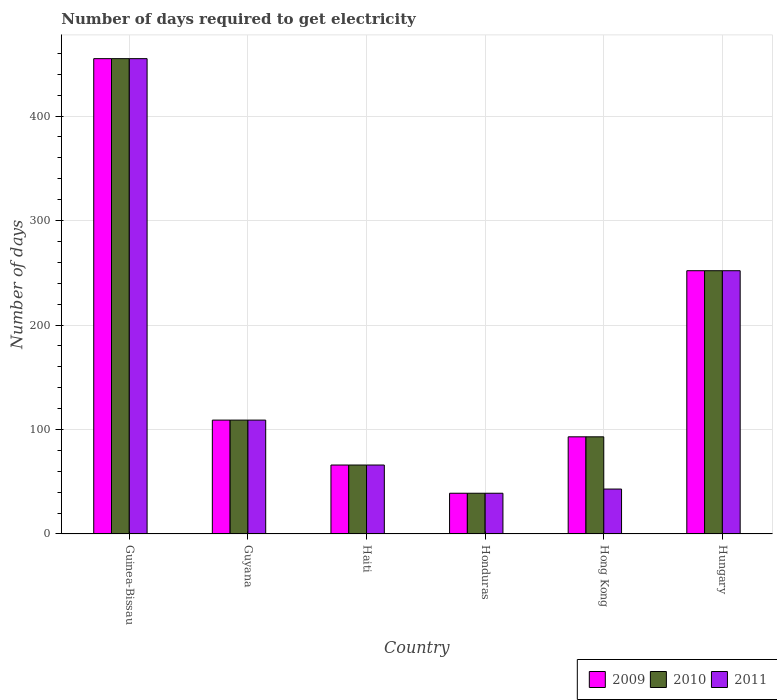Are the number of bars on each tick of the X-axis equal?
Make the answer very short. Yes. How many bars are there on the 6th tick from the right?
Offer a terse response. 3. What is the label of the 4th group of bars from the left?
Provide a succinct answer. Honduras. What is the number of days required to get electricity in in 2010 in Guyana?
Make the answer very short. 109. Across all countries, what is the maximum number of days required to get electricity in in 2009?
Give a very brief answer. 455. In which country was the number of days required to get electricity in in 2010 maximum?
Your response must be concise. Guinea-Bissau. In which country was the number of days required to get electricity in in 2011 minimum?
Offer a very short reply. Honduras. What is the total number of days required to get electricity in in 2010 in the graph?
Your answer should be very brief. 1014. What is the difference between the number of days required to get electricity in in 2009 in Guyana and that in Honduras?
Provide a succinct answer. 70. What is the average number of days required to get electricity in in 2011 per country?
Give a very brief answer. 160.67. In how many countries, is the number of days required to get electricity in in 2009 greater than 320 days?
Your answer should be compact. 1. What is the ratio of the number of days required to get electricity in in 2009 in Guyana to that in Hungary?
Provide a short and direct response. 0.43. Is the number of days required to get electricity in in 2009 in Guinea-Bissau less than that in Hong Kong?
Keep it short and to the point. No. What is the difference between the highest and the second highest number of days required to get electricity in in 2009?
Give a very brief answer. 143. What is the difference between the highest and the lowest number of days required to get electricity in in 2011?
Your answer should be very brief. 416. In how many countries, is the number of days required to get electricity in in 2009 greater than the average number of days required to get electricity in in 2009 taken over all countries?
Ensure brevity in your answer.  2. What does the 3rd bar from the left in Hungary represents?
Ensure brevity in your answer.  2011. Is it the case that in every country, the sum of the number of days required to get electricity in in 2011 and number of days required to get electricity in in 2010 is greater than the number of days required to get electricity in in 2009?
Provide a short and direct response. Yes. Are the values on the major ticks of Y-axis written in scientific E-notation?
Your answer should be very brief. No. Does the graph contain grids?
Your answer should be compact. Yes. Where does the legend appear in the graph?
Give a very brief answer. Bottom right. How many legend labels are there?
Give a very brief answer. 3. How are the legend labels stacked?
Provide a short and direct response. Horizontal. What is the title of the graph?
Offer a very short reply. Number of days required to get electricity. Does "2004" appear as one of the legend labels in the graph?
Make the answer very short. No. What is the label or title of the Y-axis?
Keep it short and to the point. Number of days. What is the Number of days in 2009 in Guinea-Bissau?
Provide a succinct answer. 455. What is the Number of days in 2010 in Guinea-Bissau?
Provide a short and direct response. 455. What is the Number of days of 2011 in Guinea-Bissau?
Provide a short and direct response. 455. What is the Number of days of 2009 in Guyana?
Ensure brevity in your answer.  109. What is the Number of days of 2010 in Guyana?
Ensure brevity in your answer.  109. What is the Number of days of 2011 in Guyana?
Your answer should be compact. 109. What is the Number of days in 2010 in Haiti?
Your response must be concise. 66. What is the Number of days in 2010 in Honduras?
Your answer should be very brief. 39. What is the Number of days in 2011 in Honduras?
Your answer should be compact. 39. What is the Number of days of 2009 in Hong Kong?
Keep it short and to the point. 93. What is the Number of days of 2010 in Hong Kong?
Offer a very short reply. 93. What is the Number of days in 2011 in Hong Kong?
Keep it short and to the point. 43. What is the Number of days in 2009 in Hungary?
Provide a short and direct response. 252. What is the Number of days of 2010 in Hungary?
Provide a succinct answer. 252. What is the Number of days in 2011 in Hungary?
Ensure brevity in your answer.  252. Across all countries, what is the maximum Number of days in 2009?
Ensure brevity in your answer.  455. Across all countries, what is the maximum Number of days in 2010?
Give a very brief answer. 455. Across all countries, what is the maximum Number of days of 2011?
Give a very brief answer. 455. Across all countries, what is the minimum Number of days in 2009?
Offer a terse response. 39. What is the total Number of days of 2009 in the graph?
Keep it short and to the point. 1014. What is the total Number of days of 2010 in the graph?
Ensure brevity in your answer.  1014. What is the total Number of days in 2011 in the graph?
Your answer should be very brief. 964. What is the difference between the Number of days in 2009 in Guinea-Bissau and that in Guyana?
Your response must be concise. 346. What is the difference between the Number of days in 2010 in Guinea-Bissau and that in Guyana?
Ensure brevity in your answer.  346. What is the difference between the Number of days of 2011 in Guinea-Bissau and that in Guyana?
Your response must be concise. 346. What is the difference between the Number of days in 2009 in Guinea-Bissau and that in Haiti?
Keep it short and to the point. 389. What is the difference between the Number of days in 2010 in Guinea-Bissau and that in Haiti?
Make the answer very short. 389. What is the difference between the Number of days of 2011 in Guinea-Bissau and that in Haiti?
Provide a short and direct response. 389. What is the difference between the Number of days of 2009 in Guinea-Bissau and that in Honduras?
Give a very brief answer. 416. What is the difference between the Number of days in 2010 in Guinea-Bissau and that in Honduras?
Your answer should be compact. 416. What is the difference between the Number of days in 2011 in Guinea-Bissau and that in Honduras?
Give a very brief answer. 416. What is the difference between the Number of days of 2009 in Guinea-Bissau and that in Hong Kong?
Give a very brief answer. 362. What is the difference between the Number of days in 2010 in Guinea-Bissau and that in Hong Kong?
Your answer should be very brief. 362. What is the difference between the Number of days of 2011 in Guinea-Bissau and that in Hong Kong?
Give a very brief answer. 412. What is the difference between the Number of days in 2009 in Guinea-Bissau and that in Hungary?
Ensure brevity in your answer.  203. What is the difference between the Number of days of 2010 in Guinea-Bissau and that in Hungary?
Provide a short and direct response. 203. What is the difference between the Number of days in 2011 in Guinea-Bissau and that in Hungary?
Your response must be concise. 203. What is the difference between the Number of days of 2009 in Guyana and that in Honduras?
Make the answer very short. 70. What is the difference between the Number of days of 2010 in Guyana and that in Honduras?
Your response must be concise. 70. What is the difference between the Number of days of 2009 in Guyana and that in Hong Kong?
Make the answer very short. 16. What is the difference between the Number of days of 2009 in Guyana and that in Hungary?
Your answer should be very brief. -143. What is the difference between the Number of days of 2010 in Guyana and that in Hungary?
Make the answer very short. -143. What is the difference between the Number of days in 2011 in Guyana and that in Hungary?
Ensure brevity in your answer.  -143. What is the difference between the Number of days of 2009 in Haiti and that in Hong Kong?
Keep it short and to the point. -27. What is the difference between the Number of days in 2010 in Haiti and that in Hong Kong?
Provide a short and direct response. -27. What is the difference between the Number of days in 2009 in Haiti and that in Hungary?
Give a very brief answer. -186. What is the difference between the Number of days in 2010 in Haiti and that in Hungary?
Keep it short and to the point. -186. What is the difference between the Number of days in 2011 in Haiti and that in Hungary?
Your answer should be compact. -186. What is the difference between the Number of days of 2009 in Honduras and that in Hong Kong?
Your response must be concise. -54. What is the difference between the Number of days of 2010 in Honduras and that in Hong Kong?
Give a very brief answer. -54. What is the difference between the Number of days of 2009 in Honduras and that in Hungary?
Give a very brief answer. -213. What is the difference between the Number of days in 2010 in Honduras and that in Hungary?
Offer a very short reply. -213. What is the difference between the Number of days of 2011 in Honduras and that in Hungary?
Your answer should be compact. -213. What is the difference between the Number of days in 2009 in Hong Kong and that in Hungary?
Ensure brevity in your answer.  -159. What is the difference between the Number of days in 2010 in Hong Kong and that in Hungary?
Your answer should be very brief. -159. What is the difference between the Number of days in 2011 in Hong Kong and that in Hungary?
Make the answer very short. -209. What is the difference between the Number of days of 2009 in Guinea-Bissau and the Number of days of 2010 in Guyana?
Give a very brief answer. 346. What is the difference between the Number of days of 2009 in Guinea-Bissau and the Number of days of 2011 in Guyana?
Your answer should be compact. 346. What is the difference between the Number of days of 2010 in Guinea-Bissau and the Number of days of 2011 in Guyana?
Your response must be concise. 346. What is the difference between the Number of days in 2009 in Guinea-Bissau and the Number of days in 2010 in Haiti?
Make the answer very short. 389. What is the difference between the Number of days in 2009 in Guinea-Bissau and the Number of days in 2011 in Haiti?
Ensure brevity in your answer.  389. What is the difference between the Number of days of 2010 in Guinea-Bissau and the Number of days of 2011 in Haiti?
Give a very brief answer. 389. What is the difference between the Number of days of 2009 in Guinea-Bissau and the Number of days of 2010 in Honduras?
Offer a very short reply. 416. What is the difference between the Number of days in 2009 in Guinea-Bissau and the Number of days in 2011 in Honduras?
Offer a very short reply. 416. What is the difference between the Number of days in 2010 in Guinea-Bissau and the Number of days in 2011 in Honduras?
Your response must be concise. 416. What is the difference between the Number of days in 2009 in Guinea-Bissau and the Number of days in 2010 in Hong Kong?
Offer a terse response. 362. What is the difference between the Number of days in 2009 in Guinea-Bissau and the Number of days in 2011 in Hong Kong?
Your answer should be compact. 412. What is the difference between the Number of days of 2010 in Guinea-Bissau and the Number of days of 2011 in Hong Kong?
Your response must be concise. 412. What is the difference between the Number of days of 2009 in Guinea-Bissau and the Number of days of 2010 in Hungary?
Offer a very short reply. 203. What is the difference between the Number of days in 2009 in Guinea-Bissau and the Number of days in 2011 in Hungary?
Offer a terse response. 203. What is the difference between the Number of days of 2010 in Guinea-Bissau and the Number of days of 2011 in Hungary?
Provide a short and direct response. 203. What is the difference between the Number of days of 2009 in Guyana and the Number of days of 2010 in Haiti?
Offer a terse response. 43. What is the difference between the Number of days of 2010 in Guyana and the Number of days of 2011 in Haiti?
Provide a succinct answer. 43. What is the difference between the Number of days in 2010 in Guyana and the Number of days in 2011 in Honduras?
Ensure brevity in your answer.  70. What is the difference between the Number of days in 2009 in Guyana and the Number of days in 2010 in Hong Kong?
Provide a short and direct response. 16. What is the difference between the Number of days in 2009 in Guyana and the Number of days in 2011 in Hong Kong?
Offer a very short reply. 66. What is the difference between the Number of days in 2010 in Guyana and the Number of days in 2011 in Hong Kong?
Your answer should be compact. 66. What is the difference between the Number of days of 2009 in Guyana and the Number of days of 2010 in Hungary?
Offer a terse response. -143. What is the difference between the Number of days of 2009 in Guyana and the Number of days of 2011 in Hungary?
Your answer should be very brief. -143. What is the difference between the Number of days of 2010 in Guyana and the Number of days of 2011 in Hungary?
Your answer should be very brief. -143. What is the difference between the Number of days in 2009 in Haiti and the Number of days in 2010 in Honduras?
Give a very brief answer. 27. What is the difference between the Number of days of 2010 in Haiti and the Number of days of 2011 in Honduras?
Keep it short and to the point. 27. What is the difference between the Number of days in 2009 in Haiti and the Number of days in 2010 in Hungary?
Make the answer very short. -186. What is the difference between the Number of days in 2009 in Haiti and the Number of days in 2011 in Hungary?
Provide a succinct answer. -186. What is the difference between the Number of days in 2010 in Haiti and the Number of days in 2011 in Hungary?
Offer a very short reply. -186. What is the difference between the Number of days of 2009 in Honduras and the Number of days of 2010 in Hong Kong?
Make the answer very short. -54. What is the difference between the Number of days in 2009 in Honduras and the Number of days in 2010 in Hungary?
Offer a very short reply. -213. What is the difference between the Number of days of 2009 in Honduras and the Number of days of 2011 in Hungary?
Offer a terse response. -213. What is the difference between the Number of days of 2010 in Honduras and the Number of days of 2011 in Hungary?
Give a very brief answer. -213. What is the difference between the Number of days of 2009 in Hong Kong and the Number of days of 2010 in Hungary?
Your response must be concise. -159. What is the difference between the Number of days of 2009 in Hong Kong and the Number of days of 2011 in Hungary?
Offer a terse response. -159. What is the difference between the Number of days in 2010 in Hong Kong and the Number of days in 2011 in Hungary?
Offer a terse response. -159. What is the average Number of days in 2009 per country?
Your answer should be compact. 169. What is the average Number of days in 2010 per country?
Provide a succinct answer. 169. What is the average Number of days of 2011 per country?
Offer a terse response. 160.67. What is the difference between the Number of days of 2009 and Number of days of 2011 in Guinea-Bissau?
Your answer should be very brief. 0. What is the difference between the Number of days of 2009 and Number of days of 2011 in Guyana?
Offer a very short reply. 0. What is the difference between the Number of days of 2010 and Number of days of 2011 in Guyana?
Provide a succinct answer. 0. What is the difference between the Number of days in 2009 and Number of days in 2011 in Haiti?
Offer a very short reply. 0. What is the difference between the Number of days of 2009 and Number of days of 2011 in Honduras?
Make the answer very short. 0. What is the difference between the Number of days of 2009 and Number of days of 2010 in Hong Kong?
Offer a very short reply. 0. What is the difference between the Number of days of 2010 and Number of days of 2011 in Hong Kong?
Your answer should be compact. 50. What is the difference between the Number of days in 2009 and Number of days in 2010 in Hungary?
Offer a very short reply. 0. What is the difference between the Number of days in 2010 and Number of days in 2011 in Hungary?
Ensure brevity in your answer.  0. What is the ratio of the Number of days of 2009 in Guinea-Bissau to that in Guyana?
Keep it short and to the point. 4.17. What is the ratio of the Number of days in 2010 in Guinea-Bissau to that in Guyana?
Offer a terse response. 4.17. What is the ratio of the Number of days of 2011 in Guinea-Bissau to that in Guyana?
Provide a short and direct response. 4.17. What is the ratio of the Number of days of 2009 in Guinea-Bissau to that in Haiti?
Offer a very short reply. 6.89. What is the ratio of the Number of days in 2010 in Guinea-Bissau to that in Haiti?
Your answer should be very brief. 6.89. What is the ratio of the Number of days in 2011 in Guinea-Bissau to that in Haiti?
Your answer should be compact. 6.89. What is the ratio of the Number of days in 2009 in Guinea-Bissau to that in Honduras?
Offer a terse response. 11.67. What is the ratio of the Number of days in 2010 in Guinea-Bissau to that in Honduras?
Make the answer very short. 11.67. What is the ratio of the Number of days in 2011 in Guinea-Bissau to that in Honduras?
Give a very brief answer. 11.67. What is the ratio of the Number of days in 2009 in Guinea-Bissau to that in Hong Kong?
Offer a very short reply. 4.89. What is the ratio of the Number of days of 2010 in Guinea-Bissau to that in Hong Kong?
Your response must be concise. 4.89. What is the ratio of the Number of days in 2011 in Guinea-Bissau to that in Hong Kong?
Offer a terse response. 10.58. What is the ratio of the Number of days in 2009 in Guinea-Bissau to that in Hungary?
Provide a short and direct response. 1.81. What is the ratio of the Number of days of 2010 in Guinea-Bissau to that in Hungary?
Offer a terse response. 1.81. What is the ratio of the Number of days in 2011 in Guinea-Bissau to that in Hungary?
Provide a short and direct response. 1.81. What is the ratio of the Number of days of 2009 in Guyana to that in Haiti?
Your response must be concise. 1.65. What is the ratio of the Number of days in 2010 in Guyana to that in Haiti?
Your response must be concise. 1.65. What is the ratio of the Number of days in 2011 in Guyana to that in Haiti?
Your answer should be very brief. 1.65. What is the ratio of the Number of days in 2009 in Guyana to that in Honduras?
Provide a short and direct response. 2.79. What is the ratio of the Number of days of 2010 in Guyana to that in Honduras?
Your answer should be very brief. 2.79. What is the ratio of the Number of days of 2011 in Guyana to that in Honduras?
Your answer should be compact. 2.79. What is the ratio of the Number of days of 2009 in Guyana to that in Hong Kong?
Offer a terse response. 1.17. What is the ratio of the Number of days of 2010 in Guyana to that in Hong Kong?
Your answer should be very brief. 1.17. What is the ratio of the Number of days of 2011 in Guyana to that in Hong Kong?
Your response must be concise. 2.53. What is the ratio of the Number of days of 2009 in Guyana to that in Hungary?
Offer a terse response. 0.43. What is the ratio of the Number of days in 2010 in Guyana to that in Hungary?
Your answer should be compact. 0.43. What is the ratio of the Number of days in 2011 in Guyana to that in Hungary?
Keep it short and to the point. 0.43. What is the ratio of the Number of days in 2009 in Haiti to that in Honduras?
Provide a succinct answer. 1.69. What is the ratio of the Number of days of 2010 in Haiti to that in Honduras?
Offer a very short reply. 1.69. What is the ratio of the Number of days in 2011 in Haiti to that in Honduras?
Provide a succinct answer. 1.69. What is the ratio of the Number of days in 2009 in Haiti to that in Hong Kong?
Offer a terse response. 0.71. What is the ratio of the Number of days of 2010 in Haiti to that in Hong Kong?
Ensure brevity in your answer.  0.71. What is the ratio of the Number of days of 2011 in Haiti to that in Hong Kong?
Offer a terse response. 1.53. What is the ratio of the Number of days in 2009 in Haiti to that in Hungary?
Give a very brief answer. 0.26. What is the ratio of the Number of days of 2010 in Haiti to that in Hungary?
Give a very brief answer. 0.26. What is the ratio of the Number of days in 2011 in Haiti to that in Hungary?
Your answer should be very brief. 0.26. What is the ratio of the Number of days of 2009 in Honduras to that in Hong Kong?
Your response must be concise. 0.42. What is the ratio of the Number of days in 2010 in Honduras to that in Hong Kong?
Offer a terse response. 0.42. What is the ratio of the Number of days in 2011 in Honduras to that in Hong Kong?
Your response must be concise. 0.91. What is the ratio of the Number of days in 2009 in Honduras to that in Hungary?
Make the answer very short. 0.15. What is the ratio of the Number of days in 2010 in Honduras to that in Hungary?
Offer a terse response. 0.15. What is the ratio of the Number of days in 2011 in Honduras to that in Hungary?
Your answer should be compact. 0.15. What is the ratio of the Number of days in 2009 in Hong Kong to that in Hungary?
Ensure brevity in your answer.  0.37. What is the ratio of the Number of days in 2010 in Hong Kong to that in Hungary?
Keep it short and to the point. 0.37. What is the ratio of the Number of days of 2011 in Hong Kong to that in Hungary?
Your answer should be very brief. 0.17. What is the difference between the highest and the second highest Number of days of 2009?
Your answer should be very brief. 203. What is the difference between the highest and the second highest Number of days of 2010?
Your response must be concise. 203. What is the difference between the highest and the second highest Number of days in 2011?
Your answer should be very brief. 203. What is the difference between the highest and the lowest Number of days in 2009?
Make the answer very short. 416. What is the difference between the highest and the lowest Number of days of 2010?
Provide a succinct answer. 416. What is the difference between the highest and the lowest Number of days in 2011?
Provide a short and direct response. 416. 